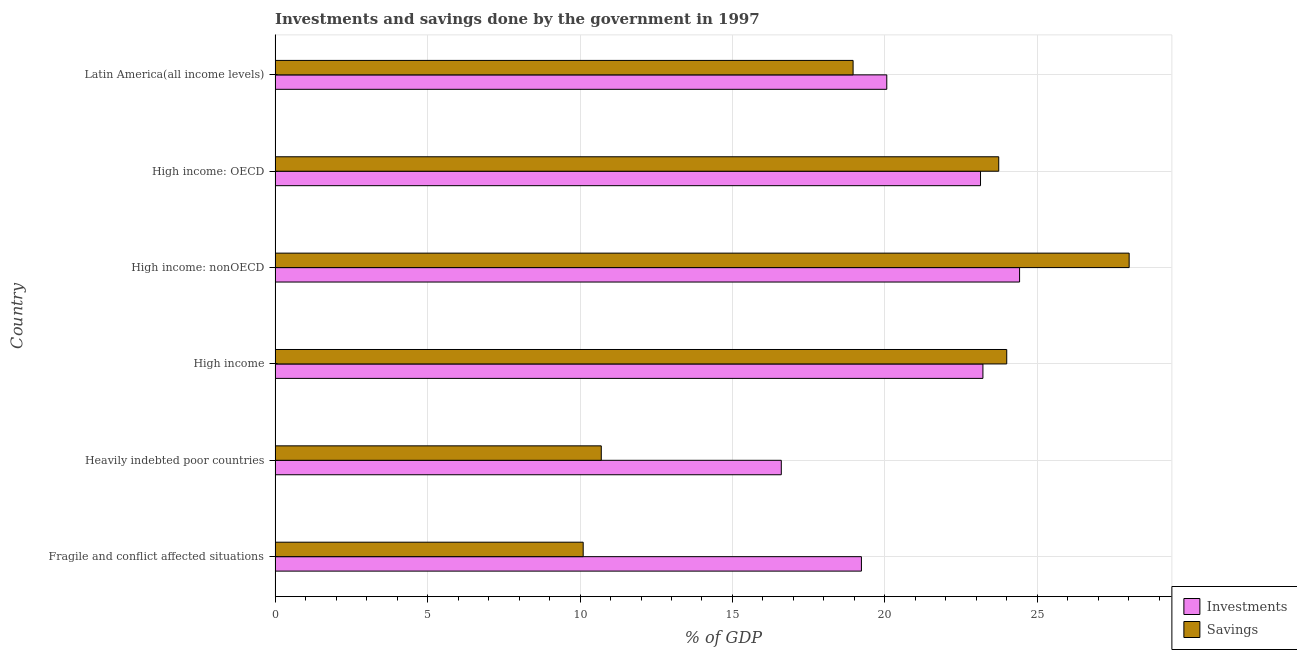Are the number of bars per tick equal to the number of legend labels?
Provide a succinct answer. Yes. How many bars are there on the 1st tick from the top?
Give a very brief answer. 2. What is the label of the 3rd group of bars from the top?
Offer a very short reply. High income: nonOECD. In how many cases, is the number of bars for a given country not equal to the number of legend labels?
Make the answer very short. 0. What is the investments of government in High income?
Provide a succinct answer. 23.21. Across all countries, what is the maximum savings of government?
Your response must be concise. 28.01. Across all countries, what is the minimum savings of government?
Give a very brief answer. 10.1. In which country was the savings of government maximum?
Offer a very short reply. High income: nonOECD. In which country was the savings of government minimum?
Ensure brevity in your answer.  Fragile and conflict affected situations. What is the total savings of government in the graph?
Make the answer very short. 115.49. What is the difference between the investments of government in High income and that in High income: OECD?
Your answer should be compact. 0.08. What is the difference between the investments of government in High income and the savings of government in High income: nonOECD?
Keep it short and to the point. -4.8. What is the average investments of government per country?
Give a very brief answer. 21.11. What is the difference between the savings of government and investments of government in High income: OECD?
Provide a short and direct response. 0.6. What is the ratio of the savings of government in High income: nonOECD to that in Latin America(all income levels)?
Make the answer very short. 1.48. What is the difference between the highest and the second highest savings of government?
Provide a short and direct response. 4.01. What is the difference between the highest and the lowest savings of government?
Give a very brief answer. 17.9. In how many countries, is the investments of government greater than the average investments of government taken over all countries?
Your answer should be very brief. 3. What does the 2nd bar from the top in High income: nonOECD represents?
Offer a terse response. Investments. What does the 2nd bar from the bottom in Heavily indebted poor countries represents?
Provide a short and direct response. Savings. How many bars are there?
Provide a short and direct response. 12. Are all the bars in the graph horizontal?
Offer a very short reply. Yes. How many countries are there in the graph?
Make the answer very short. 6. Are the values on the major ticks of X-axis written in scientific E-notation?
Your response must be concise. No. Does the graph contain any zero values?
Offer a terse response. No. How are the legend labels stacked?
Provide a succinct answer. Vertical. What is the title of the graph?
Your answer should be compact. Investments and savings done by the government in 1997. Does "Stunting" appear as one of the legend labels in the graph?
Your response must be concise. No. What is the label or title of the X-axis?
Keep it short and to the point. % of GDP. What is the label or title of the Y-axis?
Make the answer very short. Country. What is the % of GDP in Investments in Fragile and conflict affected situations?
Give a very brief answer. 19.23. What is the % of GDP of Savings in Fragile and conflict affected situations?
Provide a short and direct response. 10.1. What is the % of GDP in Investments in Heavily indebted poor countries?
Offer a terse response. 16.6. What is the % of GDP in Savings in Heavily indebted poor countries?
Offer a terse response. 10.7. What is the % of GDP in Investments in High income?
Your answer should be very brief. 23.21. What is the % of GDP in Savings in High income?
Offer a very short reply. 23.99. What is the % of GDP of Investments in High income: nonOECD?
Ensure brevity in your answer.  24.42. What is the % of GDP in Savings in High income: nonOECD?
Your answer should be very brief. 28.01. What is the % of GDP of Investments in High income: OECD?
Offer a terse response. 23.13. What is the % of GDP of Savings in High income: OECD?
Give a very brief answer. 23.73. What is the % of GDP of Investments in Latin America(all income levels)?
Your answer should be compact. 20.06. What is the % of GDP of Savings in Latin America(all income levels)?
Your response must be concise. 18.96. Across all countries, what is the maximum % of GDP in Investments?
Give a very brief answer. 24.42. Across all countries, what is the maximum % of GDP of Savings?
Your response must be concise. 28.01. Across all countries, what is the minimum % of GDP of Investments?
Your answer should be very brief. 16.6. Across all countries, what is the minimum % of GDP in Savings?
Provide a succinct answer. 10.1. What is the total % of GDP in Investments in the graph?
Make the answer very short. 126.65. What is the total % of GDP of Savings in the graph?
Give a very brief answer. 115.49. What is the difference between the % of GDP of Investments in Fragile and conflict affected situations and that in Heavily indebted poor countries?
Your answer should be compact. 2.63. What is the difference between the % of GDP in Savings in Fragile and conflict affected situations and that in Heavily indebted poor countries?
Offer a very short reply. -0.59. What is the difference between the % of GDP in Investments in Fragile and conflict affected situations and that in High income?
Your answer should be very brief. -3.98. What is the difference between the % of GDP of Savings in Fragile and conflict affected situations and that in High income?
Offer a very short reply. -13.89. What is the difference between the % of GDP of Investments in Fragile and conflict affected situations and that in High income: nonOECD?
Offer a terse response. -5.19. What is the difference between the % of GDP of Savings in Fragile and conflict affected situations and that in High income: nonOECD?
Give a very brief answer. -17.91. What is the difference between the % of GDP of Investments in Fragile and conflict affected situations and that in High income: OECD?
Make the answer very short. -3.91. What is the difference between the % of GDP of Savings in Fragile and conflict affected situations and that in High income: OECD?
Offer a very short reply. -13.63. What is the difference between the % of GDP in Investments in Fragile and conflict affected situations and that in Latin America(all income levels)?
Your answer should be very brief. -0.83. What is the difference between the % of GDP in Savings in Fragile and conflict affected situations and that in Latin America(all income levels)?
Provide a short and direct response. -8.85. What is the difference between the % of GDP in Investments in Heavily indebted poor countries and that in High income?
Ensure brevity in your answer.  -6.61. What is the difference between the % of GDP of Savings in Heavily indebted poor countries and that in High income?
Your answer should be very brief. -13.3. What is the difference between the % of GDP of Investments in Heavily indebted poor countries and that in High income: nonOECD?
Your answer should be compact. -7.81. What is the difference between the % of GDP in Savings in Heavily indebted poor countries and that in High income: nonOECD?
Keep it short and to the point. -17.31. What is the difference between the % of GDP of Investments in Heavily indebted poor countries and that in High income: OECD?
Keep it short and to the point. -6.53. What is the difference between the % of GDP of Savings in Heavily indebted poor countries and that in High income: OECD?
Your response must be concise. -13.03. What is the difference between the % of GDP in Investments in Heavily indebted poor countries and that in Latin America(all income levels)?
Keep it short and to the point. -3.46. What is the difference between the % of GDP in Savings in Heavily indebted poor countries and that in Latin America(all income levels)?
Ensure brevity in your answer.  -8.26. What is the difference between the % of GDP in Investments in High income and that in High income: nonOECD?
Your answer should be very brief. -1.2. What is the difference between the % of GDP of Savings in High income and that in High income: nonOECD?
Your response must be concise. -4.01. What is the difference between the % of GDP of Investments in High income and that in High income: OECD?
Provide a short and direct response. 0.08. What is the difference between the % of GDP of Savings in High income and that in High income: OECD?
Ensure brevity in your answer.  0.26. What is the difference between the % of GDP of Investments in High income and that in Latin America(all income levels)?
Offer a terse response. 3.15. What is the difference between the % of GDP of Savings in High income and that in Latin America(all income levels)?
Your answer should be very brief. 5.04. What is the difference between the % of GDP of Investments in High income: nonOECD and that in High income: OECD?
Your response must be concise. 1.28. What is the difference between the % of GDP of Savings in High income: nonOECD and that in High income: OECD?
Your response must be concise. 4.28. What is the difference between the % of GDP in Investments in High income: nonOECD and that in Latin America(all income levels)?
Provide a short and direct response. 4.35. What is the difference between the % of GDP of Savings in High income: nonOECD and that in Latin America(all income levels)?
Provide a succinct answer. 9.05. What is the difference between the % of GDP of Investments in High income: OECD and that in Latin America(all income levels)?
Keep it short and to the point. 3.07. What is the difference between the % of GDP of Savings in High income: OECD and that in Latin America(all income levels)?
Your answer should be very brief. 4.78. What is the difference between the % of GDP of Investments in Fragile and conflict affected situations and the % of GDP of Savings in Heavily indebted poor countries?
Provide a short and direct response. 8.53. What is the difference between the % of GDP in Investments in Fragile and conflict affected situations and the % of GDP in Savings in High income?
Make the answer very short. -4.77. What is the difference between the % of GDP in Investments in Fragile and conflict affected situations and the % of GDP in Savings in High income: nonOECD?
Your answer should be very brief. -8.78. What is the difference between the % of GDP in Investments in Fragile and conflict affected situations and the % of GDP in Savings in High income: OECD?
Offer a terse response. -4.5. What is the difference between the % of GDP in Investments in Fragile and conflict affected situations and the % of GDP in Savings in Latin America(all income levels)?
Make the answer very short. 0.27. What is the difference between the % of GDP in Investments in Heavily indebted poor countries and the % of GDP in Savings in High income?
Your response must be concise. -7.39. What is the difference between the % of GDP of Investments in Heavily indebted poor countries and the % of GDP of Savings in High income: nonOECD?
Offer a very short reply. -11.41. What is the difference between the % of GDP of Investments in Heavily indebted poor countries and the % of GDP of Savings in High income: OECD?
Give a very brief answer. -7.13. What is the difference between the % of GDP of Investments in Heavily indebted poor countries and the % of GDP of Savings in Latin America(all income levels)?
Give a very brief answer. -2.35. What is the difference between the % of GDP in Investments in High income and the % of GDP in Savings in High income: nonOECD?
Make the answer very short. -4.8. What is the difference between the % of GDP of Investments in High income and the % of GDP of Savings in High income: OECD?
Offer a terse response. -0.52. What is the difference between the % of GDP in Investments in High income and the % of GDP in Savings in Latin America(all income levels)?
Offer a terse response. 4.26. What is the difference between the % of GDP in Investments in High income: nonOECD and the % of GDP in Savings in High income: OECD?
Your answer should be compact. 0.68. What is the difference between the % of GDP of Investments in High income: nonOECD and the % of GDP of Savings in Latin America(all income levels)?
Provide a short and direct response. 5.46. What is the difference between the % of GDP in Investments in High income: OECD and the % of GDP in Savings in Latin America(all income levels)?
Offer a terse response. 4.18. What is the average % of GDP of Investments per country?
Provide a short and direct response. 21.11. What is the average % of GDP of Savings per country?
Your answer should be compact. 19.25. What is the difference between the % of GDP in Investments and % of GDP in Savings in Fragile and conflict affected situations?
Provide a short and direct response. 9.12. What is the difference between the % of GDP in Investments and % of GDP in Savings in Heavily indebted poor countries?
Offer a terse response. 5.9. What is the difference between the % of GDP in Investments and % of GDP in Savings in High income?
Your response must be concise. -0.78. What is the difference between the % of GDP of Investments and % of GDP of Savings in High income: nonOECD?
Keep it short and to the point. -3.59. What is the difference between the % of GDP in Investments and % of GDP in Savings in High income: OECD?
Offer a very short reply. -0.6. What is the difference between the % of GDP in Investments and % of GDP in Savings in Latin America(all income levels)?
Give a very brief answer. 1.1. What is the ratio of the % of GDP in Investments in Fragile and conflict affected situations to that in Heavily indebted poor countries?
Make the answer very short. 1.16. What is the ratio of the % of GDP in Savings in Fragile and conflict affected situations to that in Heavily indebted poor countries?
Offer a very short reply. 0.94. What is the ratio of the % of GDP in Investments in Fragile and conflict affected situations to that in High income?
Offer a terse response. 0.83. What is the ratio of the % of GDP of Savings in Fragile and conflict affected situations to that in High income?
Keep it short and to the point. 0.42. What is the ratio of the % of GDP of Investments in Fragile and conflict affected situations to that in High income: nonOECD?
Offer a very short reply. 0.79. What is the ratio of the % of GDP in Savings in Fragile and conflict affected situations to that in High income: nonOECD?
Provide a short and direct response. 0.36. What is the ratio of the % of GDP in Investments in Fragile and conflict affected situations to that in High income: OECD?
Offer a very short reply. 0.83. What is the ratio of the % of GDP in Savings in Fragile and conflict affected situations to that in High income: OECD?
Keep it short and to the point. 0.43. What is the ratio of the % of GDP of Investments in Fragile and conflict affected situations to that in Latin America(all income levels)?
Offer a terse response. 0.96. What is the ratio of the % of GDP of Savings in Fragile and conflict affected situations to that in Latin America(all income levels)?
Your response must be concise. 0.53. What is the ratio of the % of GDP in Investments in Heavily indebted poor countries to that in High income?
Your answer should be compact. 0.72. What is the ratio of the % of GDP in Savings in Heavily indebted poor countries to that in High income?
Make the answer very short. 0.45. What is the ratio of the % of GDP in Investments in Heavily indebted poor countries to that in High income: nonOECD?
Your response must be concise. 0.68. What is the ratio of the % of GDP of Savings in Heavily indebted poor countries to that in High income: nonOECD?
Provide a succinct answer. 0.38. What is the ratio of the % of GDP in Investments in Heavily indebted poor countries to that in High income: OECD?
Keep it short and to the point. 0.72. What is the ratio of the % of GDP in Savings in Heavily indebted poor countries to that in High income: OECD?
Your answer should be very brief. 0.45. What is the ratio of the % of GDP in Investments in Heavily indebted poor countries to that in Latin America(all income levels)?
Keep it short and to the point. 0.83. What is the ratio of the % of GDP of Savings in Heavily indebted poor countries to that in Latin America(all income levels)?
Offer a very short reply. 0.56. What is the ratio of the % of GDP of Investments in High income to that in High income: nonOECD?
Your answer should be compact. 0.95. What is the ratio of the % of GDP in Savings in High income to that in High income: nonOECD?
Your response must be concise. 0.86. What is the ratio of the % of GDP in Investments in High income to that in High income: OECD?
Provide a succinct answer. 1. What is the ratio of the % of GDP in Savings in High income to that in High income: OECD?
Make the answer very short. 1.01. What is the ratio of the % of GDP of Investments in High income to that in Latin America(all income levels)?
Your answer should be very brief. 1.16. What is the ratio of the % of GDP of Savings in High income to that in Latin America(all income levels)?
Your answer should be very brief. 1.27. What is the ratio of the % of GDP of Investments in High income: nonOECD to that in High income: OECD?
Keep it short and to the point. 1.06. What is the ratio of the % of GDP in Savings in High income: nonOECD to that in High income: OECD?
Your answer should be compact. 1.18. What is the ratio of the % of GDP in Investments in High income: nonOECD to that in Latin America(all income levels)?
Offer a very short reply. 1.22. What is the ratio of the % of GDP in Savings in High income: nonOECD to that in Latin America(all income levels)?
Your answer should be compact. 1.48. What is the ratio of the % of GDP of Investments in High income: OECD to that in Latin America(all income levels)?
Your response must be concise. 1.15. What is the ratio of the % of GDP in Savings in High income: OECD to that in Latin America(all income levels)?
Give a very brief answer. 1.25. What is the difference between the highest and the second highest % of GDP in Investments?
Keep it short and to the point. 1.2. What is the difference between the highest and the second highest % of GDP of Savings?
Provide a short and direct response. 4.01. What is the difference between the highest and the lowest % of GDP of Investments?
Offer a terse response. 7.81. What is the difference between the highest and the lowest % of GDP of Savings?
Your answer should be compact. 17.91. 